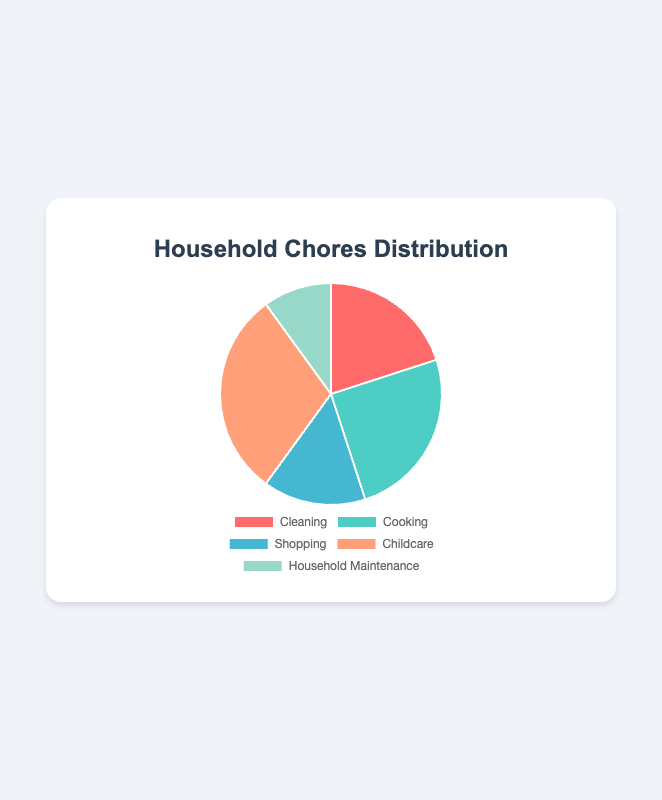Which chore takes up the largest percentage of our household tasks? Childcare has the highest percentage at 30%. You can see that the largest slice of the pie chart corresponds to childcare.
Answer: Childcare How much more percentage does cooking take up compared to household maintenance? Cooking takes up 25%, while household maintenance takes up 10%. The difference is 25% - 10% = 15%.
Answer: 15% What is the total percentage of cleaning and shopping combined? Cleaning takes up 20% and shopping takes up 15%. The combined total is 20% + 15% = 35%.
Answer: 35% Which chore is represented by the green slice? Visual inspection of the green slice shows it's labeled childcare, which corresponds to 30%.
Answer: Childcare If we redistribute 5% from childcare to shopping, what will be the new percentage for shopping? Currently, shopping is 15% and childcare is 30%. Redistributing 5% from childcare to shopping makes shopping 15% + 5% = 20%.
Answer: 20% Among the chores, which two have the smallest percentages? The smallest percentages are household maintenance at 10% and shopping at 15%. The smaller slices in the pie chart confirm these values.
Answer: Household maintenance and shopping What is the average percentage of all household chores? Summing up the percentages: 20% (cleaning) + 25% (cooking) + 15% (shopping) + 30% (childcare) + 10% (household maintenance) = 100%. The average is 100% / 5 = 20%.
Answer: 20% Which chore takes up a quarter of the total household tasks? Cooking is 25% of the total, which is equivalent to a quarter (25/100). You can confirm this by seeing the slice that represents cooking.
Answer: Cooking 